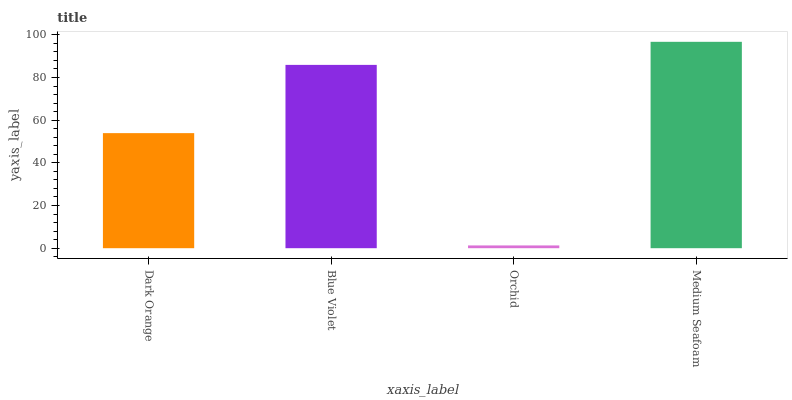Is Blue Violet the minimum?
Answer yes or no. No. Is Blue Violet the maximum?
Answer yes or no. No. Is Blue Violet greater than Dark Orange?
Answer yes or no. Yes. Is Dark Orange less than Blue Violet?
Answer yes or no. Yes. Is Dark Orange greater than Blue Violet?
Answer yes or no. No. Is Blue Violet less than Dark Orange?
Answer yes or no. No. Is Blue Violet the high median?
Answer yes or no. Yes. Is Dark Orange the low median?
Answer yes or no. Yes. Is Dark Orange the high median?
Answer yes or no. No. Is Orchid the low median?
Answer yes or no. No. 